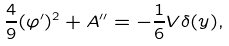<formula> <loc_0><loc_0><loc_500><loc_500>\frac { 4 } { 9 } ( \varphi ^ { \prime } ) ^ { 2 } + A ^ { \prime \prime } = - \frac { 1 } { 6 } V \delta ( y ) ,</formula> 